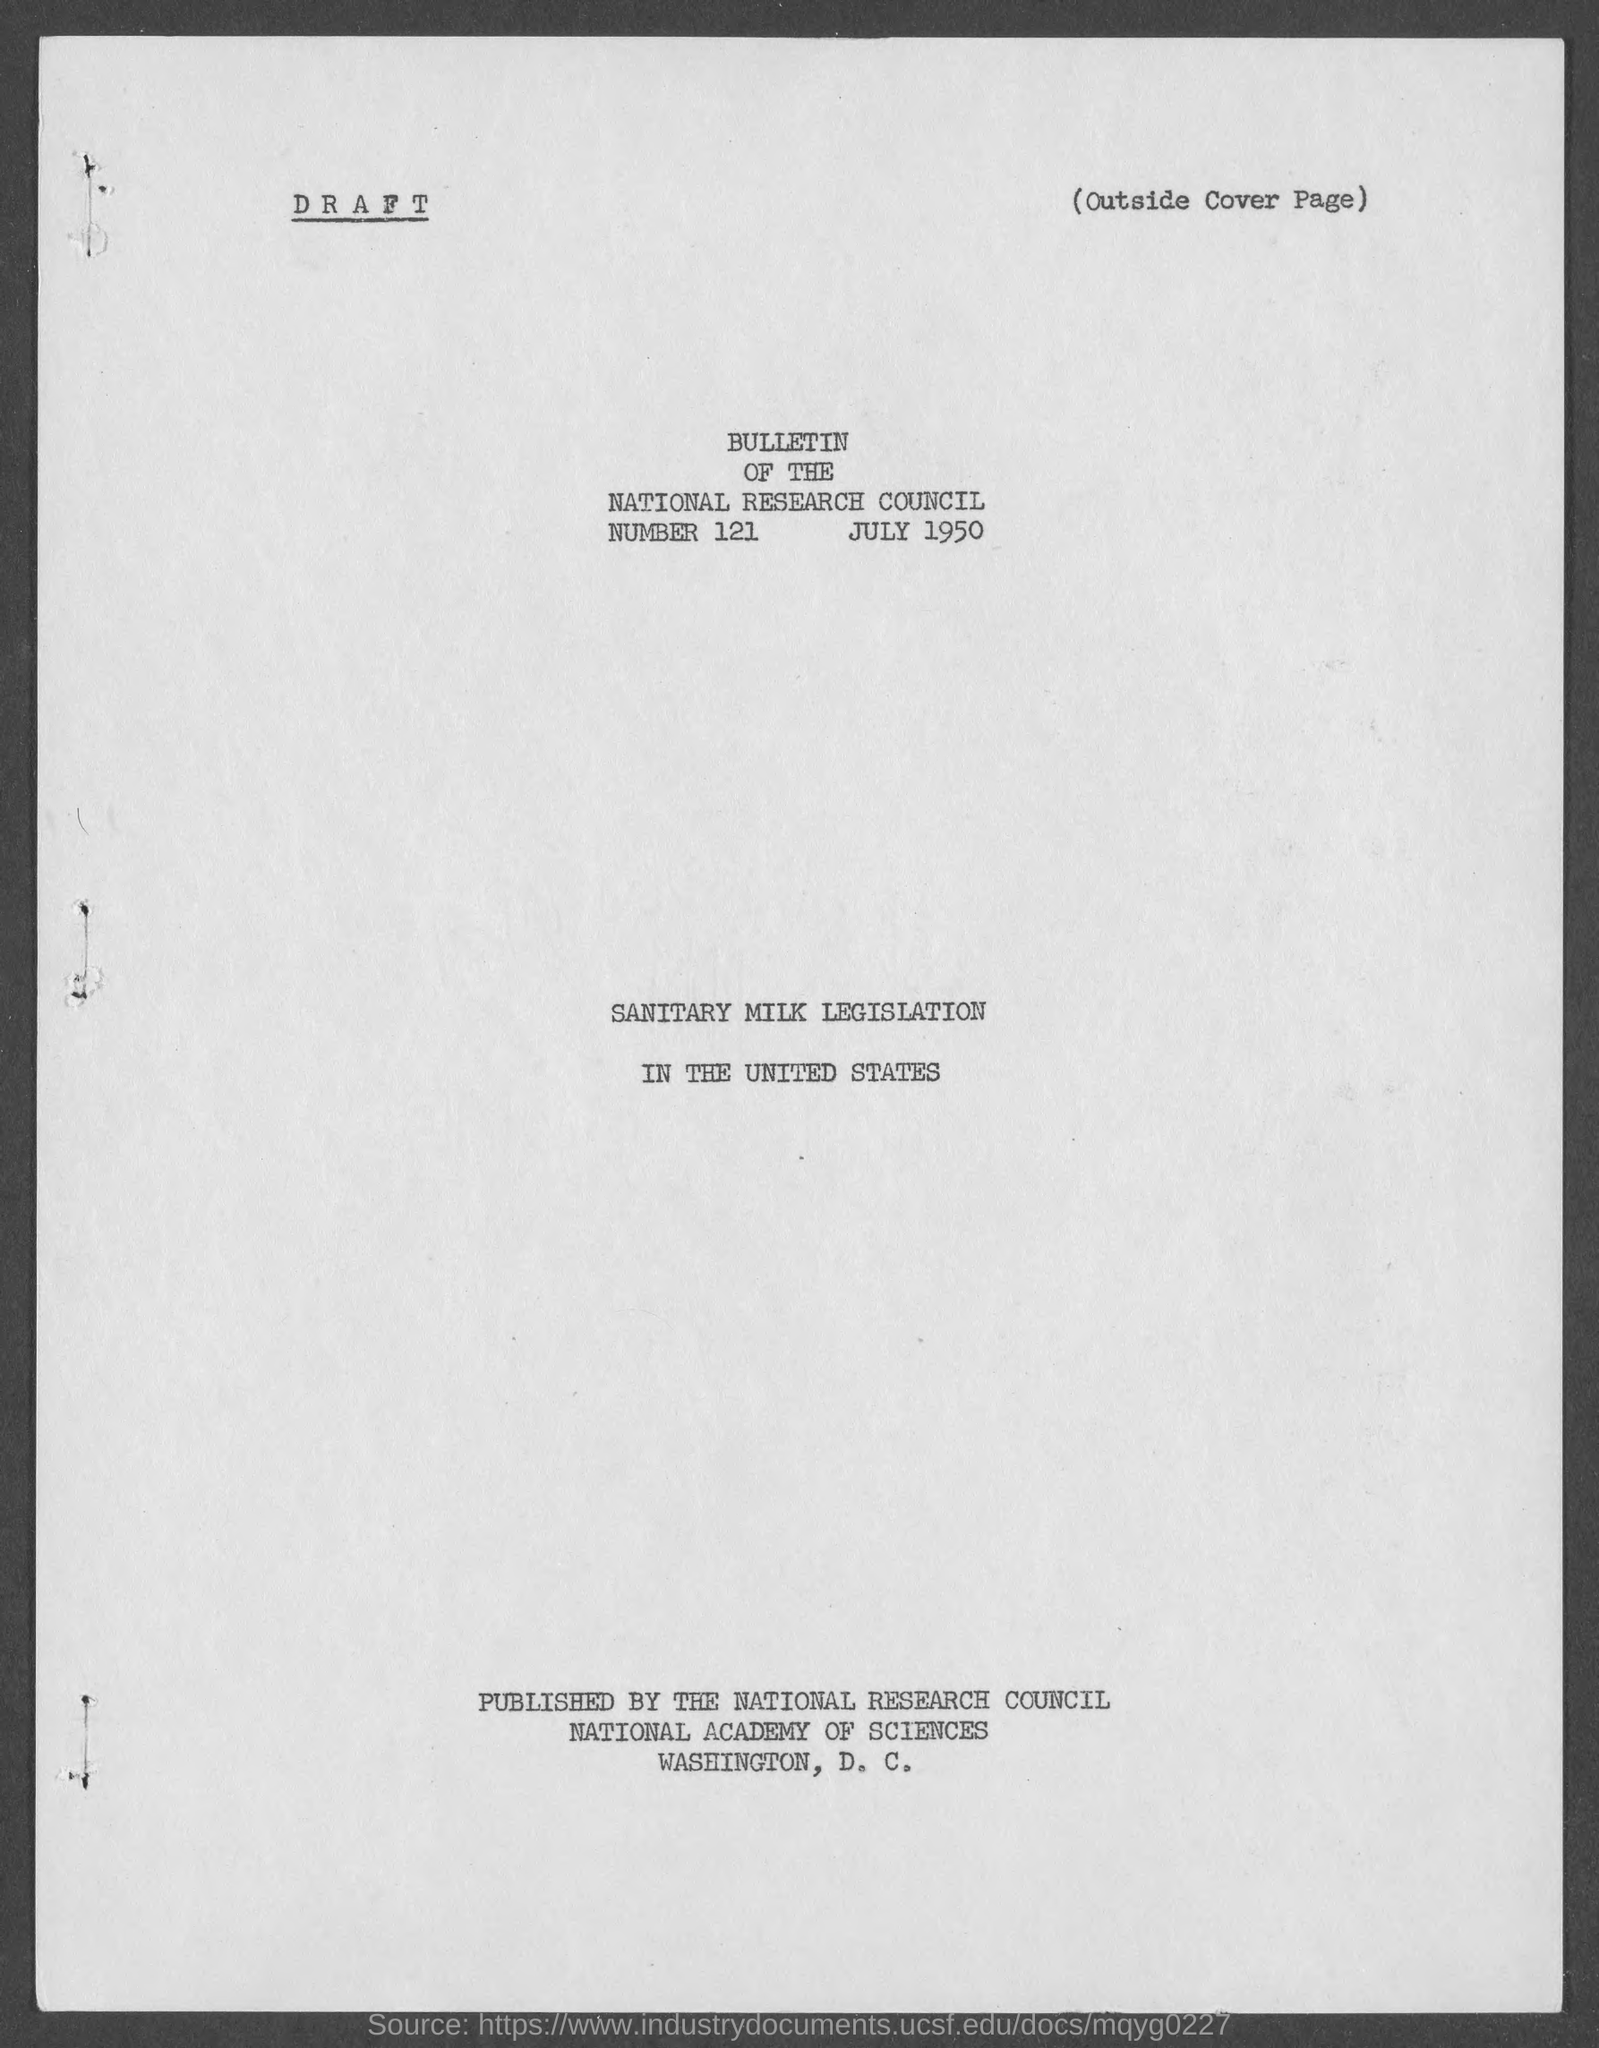What is the bulletin number of national research council ?
Make the answer very short. 121. 